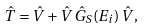<formula> <loc_0><loc_0><loc_500><loc_500>\hat { T } = \hat { V } + \hat { V } \, \hat { G } _ { S } ( E _ { i } ) \, \hat { V } ,</formula> 